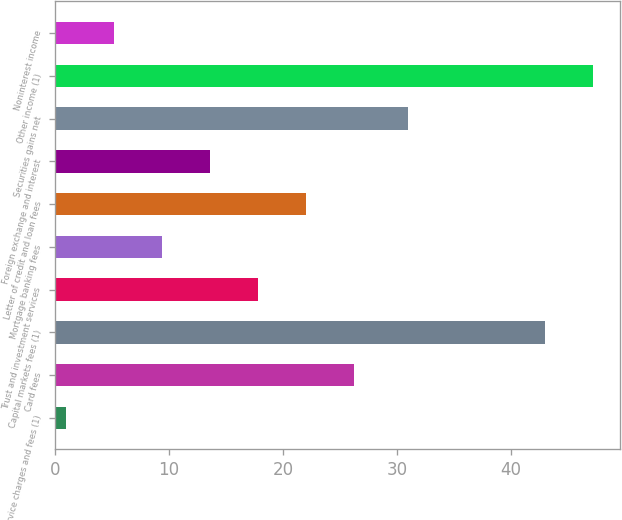Convert chart to OTSL. <chart><loc_0><loc_0><loc_500><loc_500><bar_chart><fcel>Service charges and fees (1)<fcel>Card fees<fcel>Capital markets fees (1)<fcel>Trust and investment services<fcel>Mortgage banking fees<fcel>Letter of credit and loan fees<fcel>Foreign exchange and interest<fcel>Securities gains net<fcel>Other income (1)<fcel>Noninterest income<nl><fcel>1<fcel>26.2<fcel>43<fcel>17.8<fcel>9.4<fcel>22<fcel>13.6<fcel>31<fcel>47.2<fcel>5.2<nl></chart> 